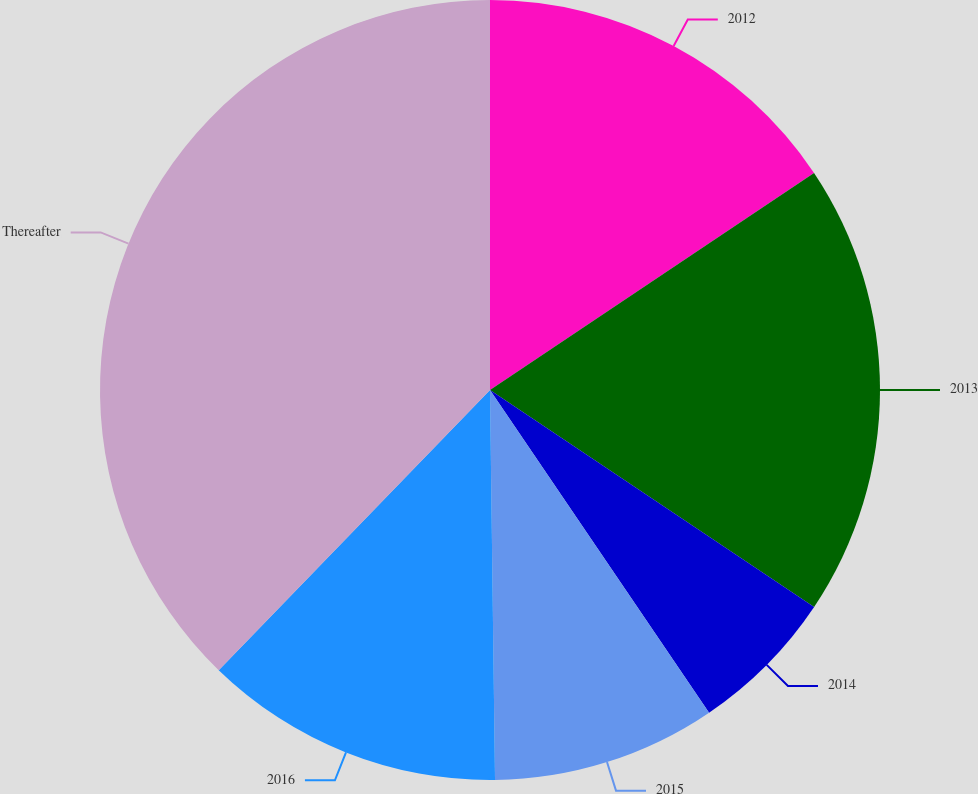<chart> <loc_0><loc_0><loc_500><loc_500><pie_chart><fcel>2012<fcel>2013<fcel>2014<fcel>2015<fcel>2016<fcel>Thereafter<nl><fcel>15.61%<fcel>18.78%<fcel>6.12%<fcel>9.29%<fcel>12.45%<fcel>37.76%<nl></chart> 